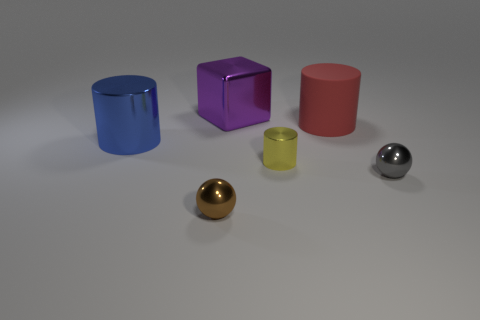What material is the yellow thing?
Offer a very short reply. Metal. Is the shape of the big thing that is on the right side of the yellow metallic object the same as  the gray metallic thing?
Ensure brevity in your answer.  No. Are there any things that have the same size as the brown ball?
Provide a short and direct response. Yes. There is a shiny object that is behind the red rubber thing that is on the right side of the big blue metal thing; are there any tiny spheres that are in front of it?
Your answer should be very brief. Yes. What is the material of the tiny ball that is left of the big cylinder behind the large thing left of the purple metal block?
Your answer should be compact. Metal. There is a shiny thing that is to the right of the red matte thing; what is its shape?
Provide a short and direct response. Sphere. What size is the gray sphere that is made of the same material as the blue thing?
Offer a very short reply. Small. How many other tiny red objects have the same shape as the red rubber object?
Offer a terse response. 0. There is a shiny object that is behind the big metallic thing that is to the left of the big purple object; how many small shiny balls are in front of it?
Ensure brevity in your answer.  2. What number of things are both in front of the big red cylinder and left of the gray thing?
Make the answer very short. 3. 